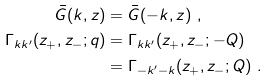Convert formula to latex. <formula><loc_0><loc_0><loc_500><loc_500>\bar { G } ( k , z ) & = \bar { G } ( - k , z ) \ , \\ \Gamma _ { k k ^ { \prime } } ( z _ { + } , z _ { - } ; q ) & = \Gamma _ { k k ^ { \prime } } ( z _ { + } , z _ { - } ; - Q ) \\ & = \Gamma _ { - k ^ { \prime } - k } ( z _ { + } , z _ { - } ; Q ) \ .</formula> 